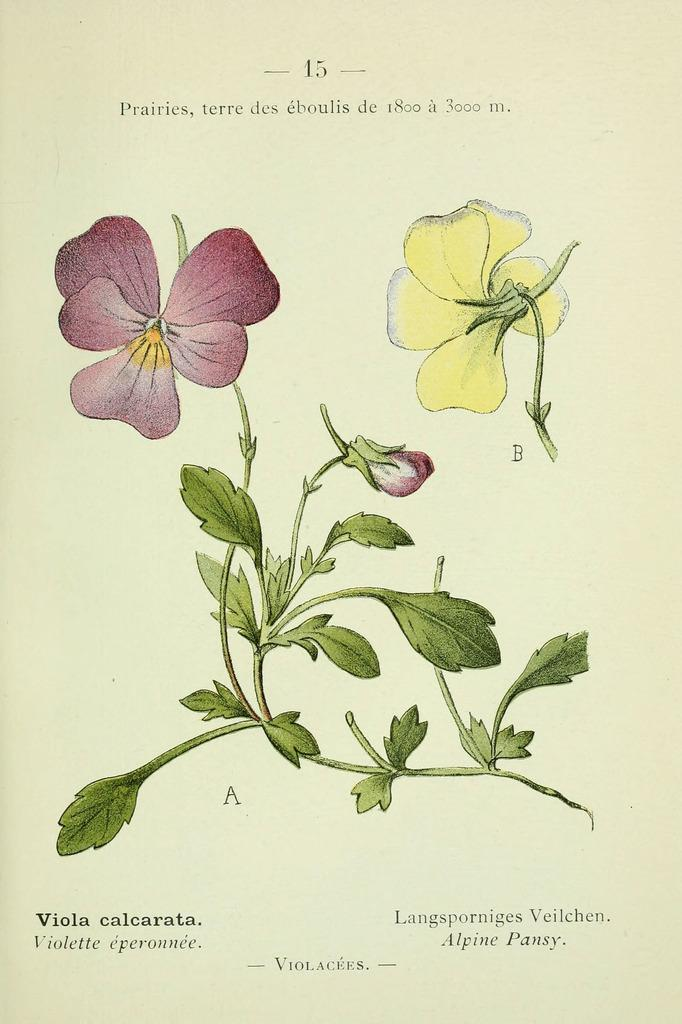What is depicted on the page in the image? The page contains a stem with leaves, a flower, and a bud. What color is the flower on the page? There is a yellow flower on the page. What is written on the page? Something is written on the page. Can you tell me how many firemen are present in the image? There are no firemen present in the image; it features a stem, leaves, a flower, and a bud on a page with writing. Is there a farm visible in the image? There is no farm present in the image; it features a stem, leaves, a flower, and a bud on a page with writing. 